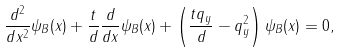<formula> <loc_0><loc_0><loc_500><loc_500>\frac { d ^ { 2 } } { d x ^ { 2 } } \psi _ { B } ( x ) + \frac { t } { d } \frac { d } { d x } \psi _ { B } ( x ) + \left ( \frac { t q _ { y } } { d } - q _ { y } ^ { 2 } \right ) \psi _ { B } ( x ) = 0 ,</formula> 